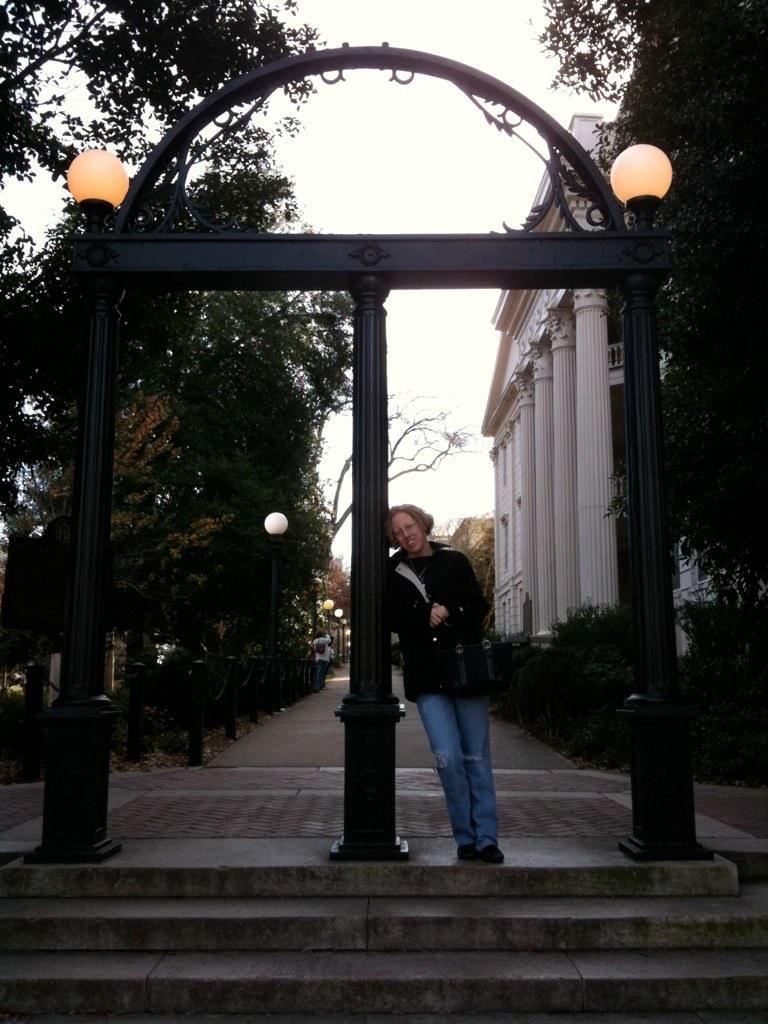Could you give a brief overview of what you see in this image? In this image I can see in the middle a person is standing, at the top there are lights. On the right side there is a building, there are trees on either side of this image. At the top it is the sky. 